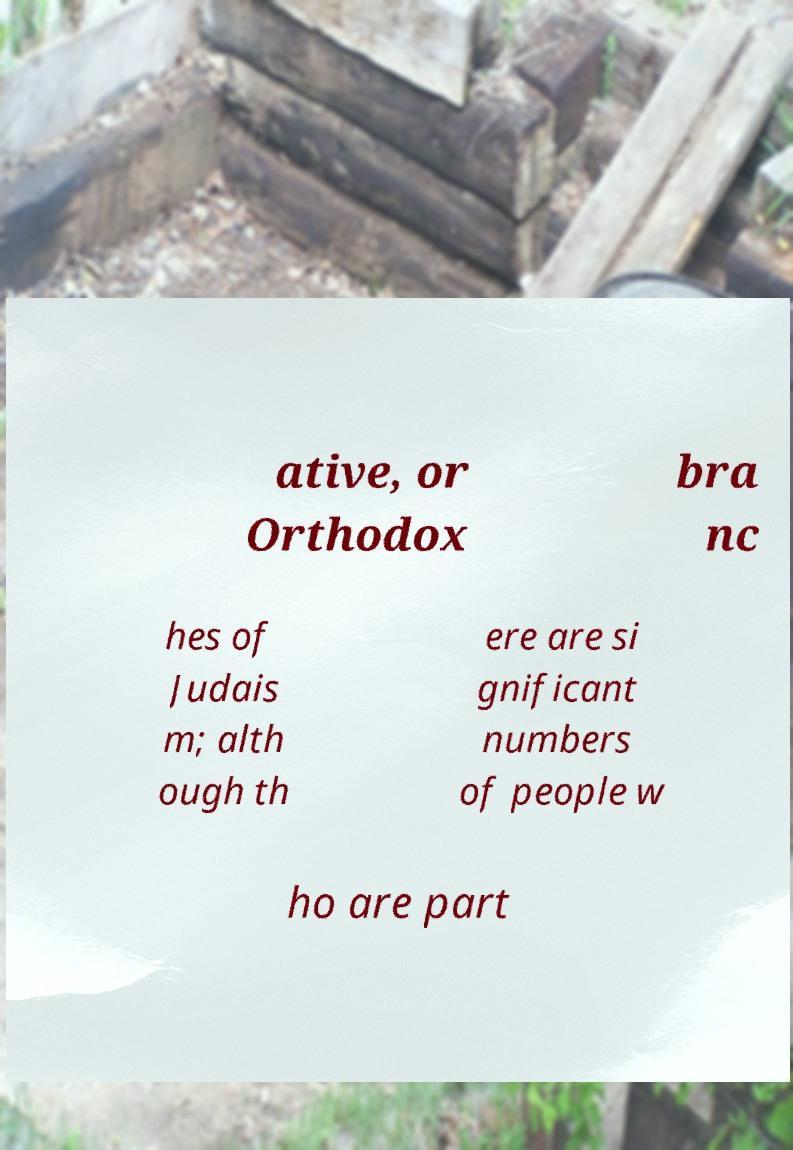Can you read and provide the text displayed in the image?This photo seems to have some interesting text. Can you extract and type it out for me? ative, or Orthodox bra nc hes of Judais m; alth ough th ere are si gnificant numbers of people w ho are part 